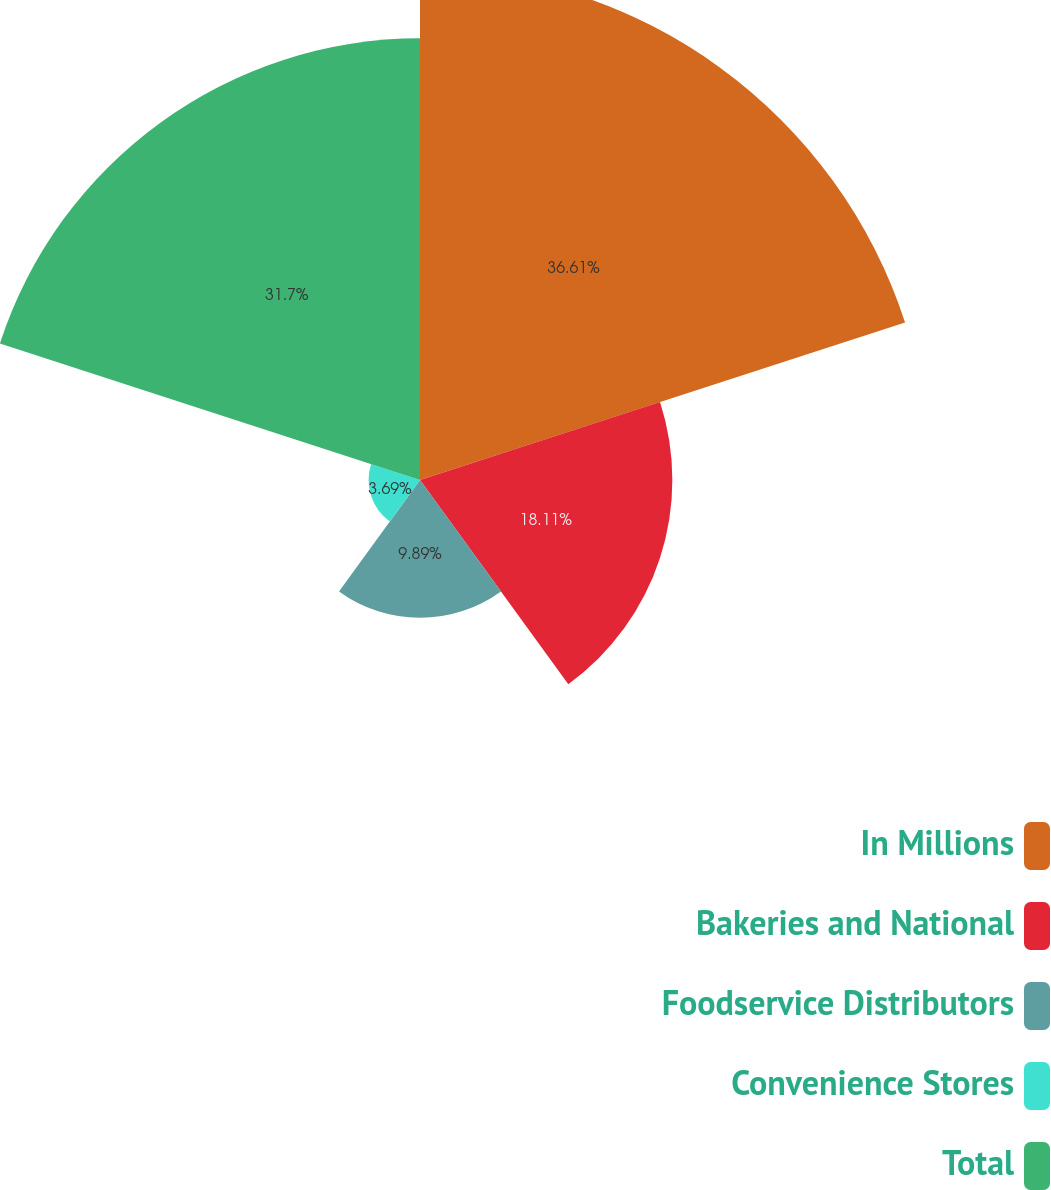Convert chart. <chart><loc_0><loc_0><loc_500><loc_500><pie_chart><fcel>In Millions<fcel>Bakeries and National<fcel>Foodservice Distributors<fcel>Convenience Stores<fcel>Total<nl><fcel>36.6%<fcel>18.11%<fcel>9.89%<fcel>3.69%<fcel>31.7%<nl></chart> 